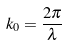<formula> <loc_0><loc_0><loc_500><loc_500>k _ { 0 } = \frac { 2 \pi } { \lambda }</formula> 